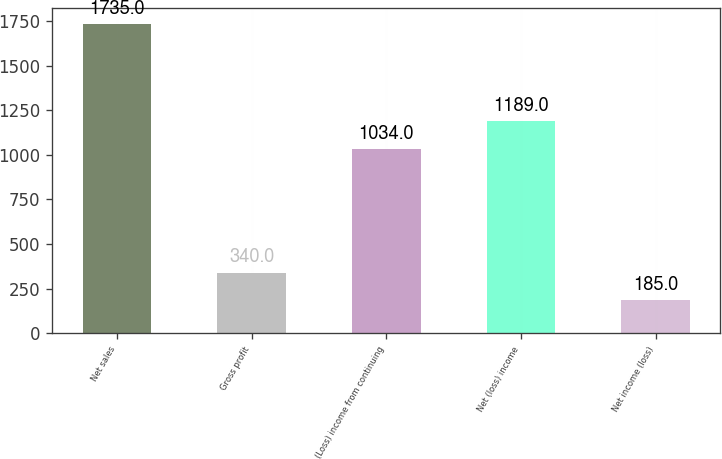Convert chart to OTSL. <chart><loc_0><loc_0><loc_500><loc_500><bar_chart><fcel>Net sales<fcel>Gross profit<fcel>(Loss) income from continuing<fcel>Net (loss) income<fcel>Net income (loss)<nl><fcel>1735<fcel>340<fcel>1034<fcel>1189<fcel>185<nl></chart> 